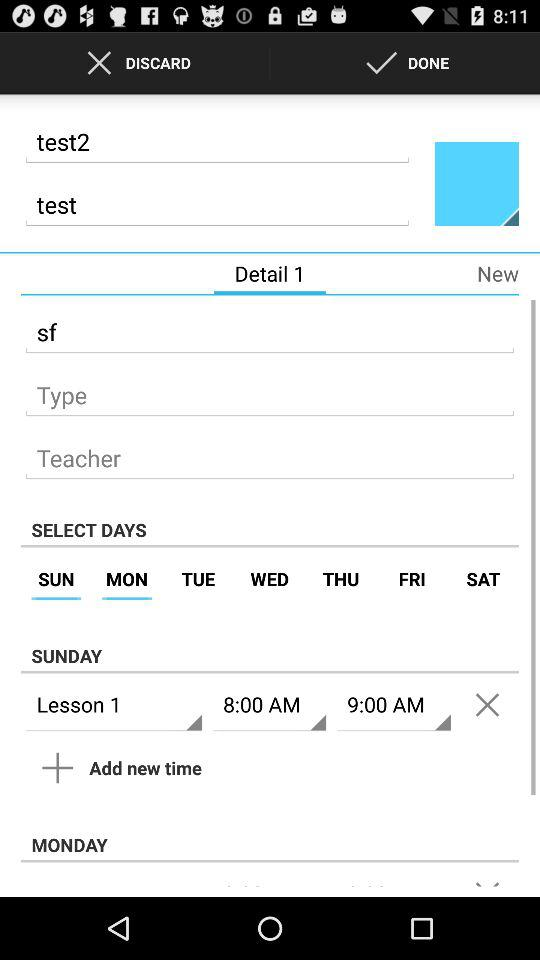What are the selected days for the test? The selected days are Sunday and Monday. 